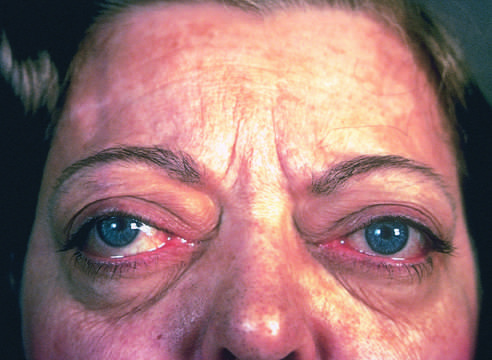does one of the most important causes of hyperthyroidism, accumulation of loose connective tissue behind the orbits add to the protuberant appearance of the eyes in graves disease?
Answer the question using a single word or phrase. Yes 